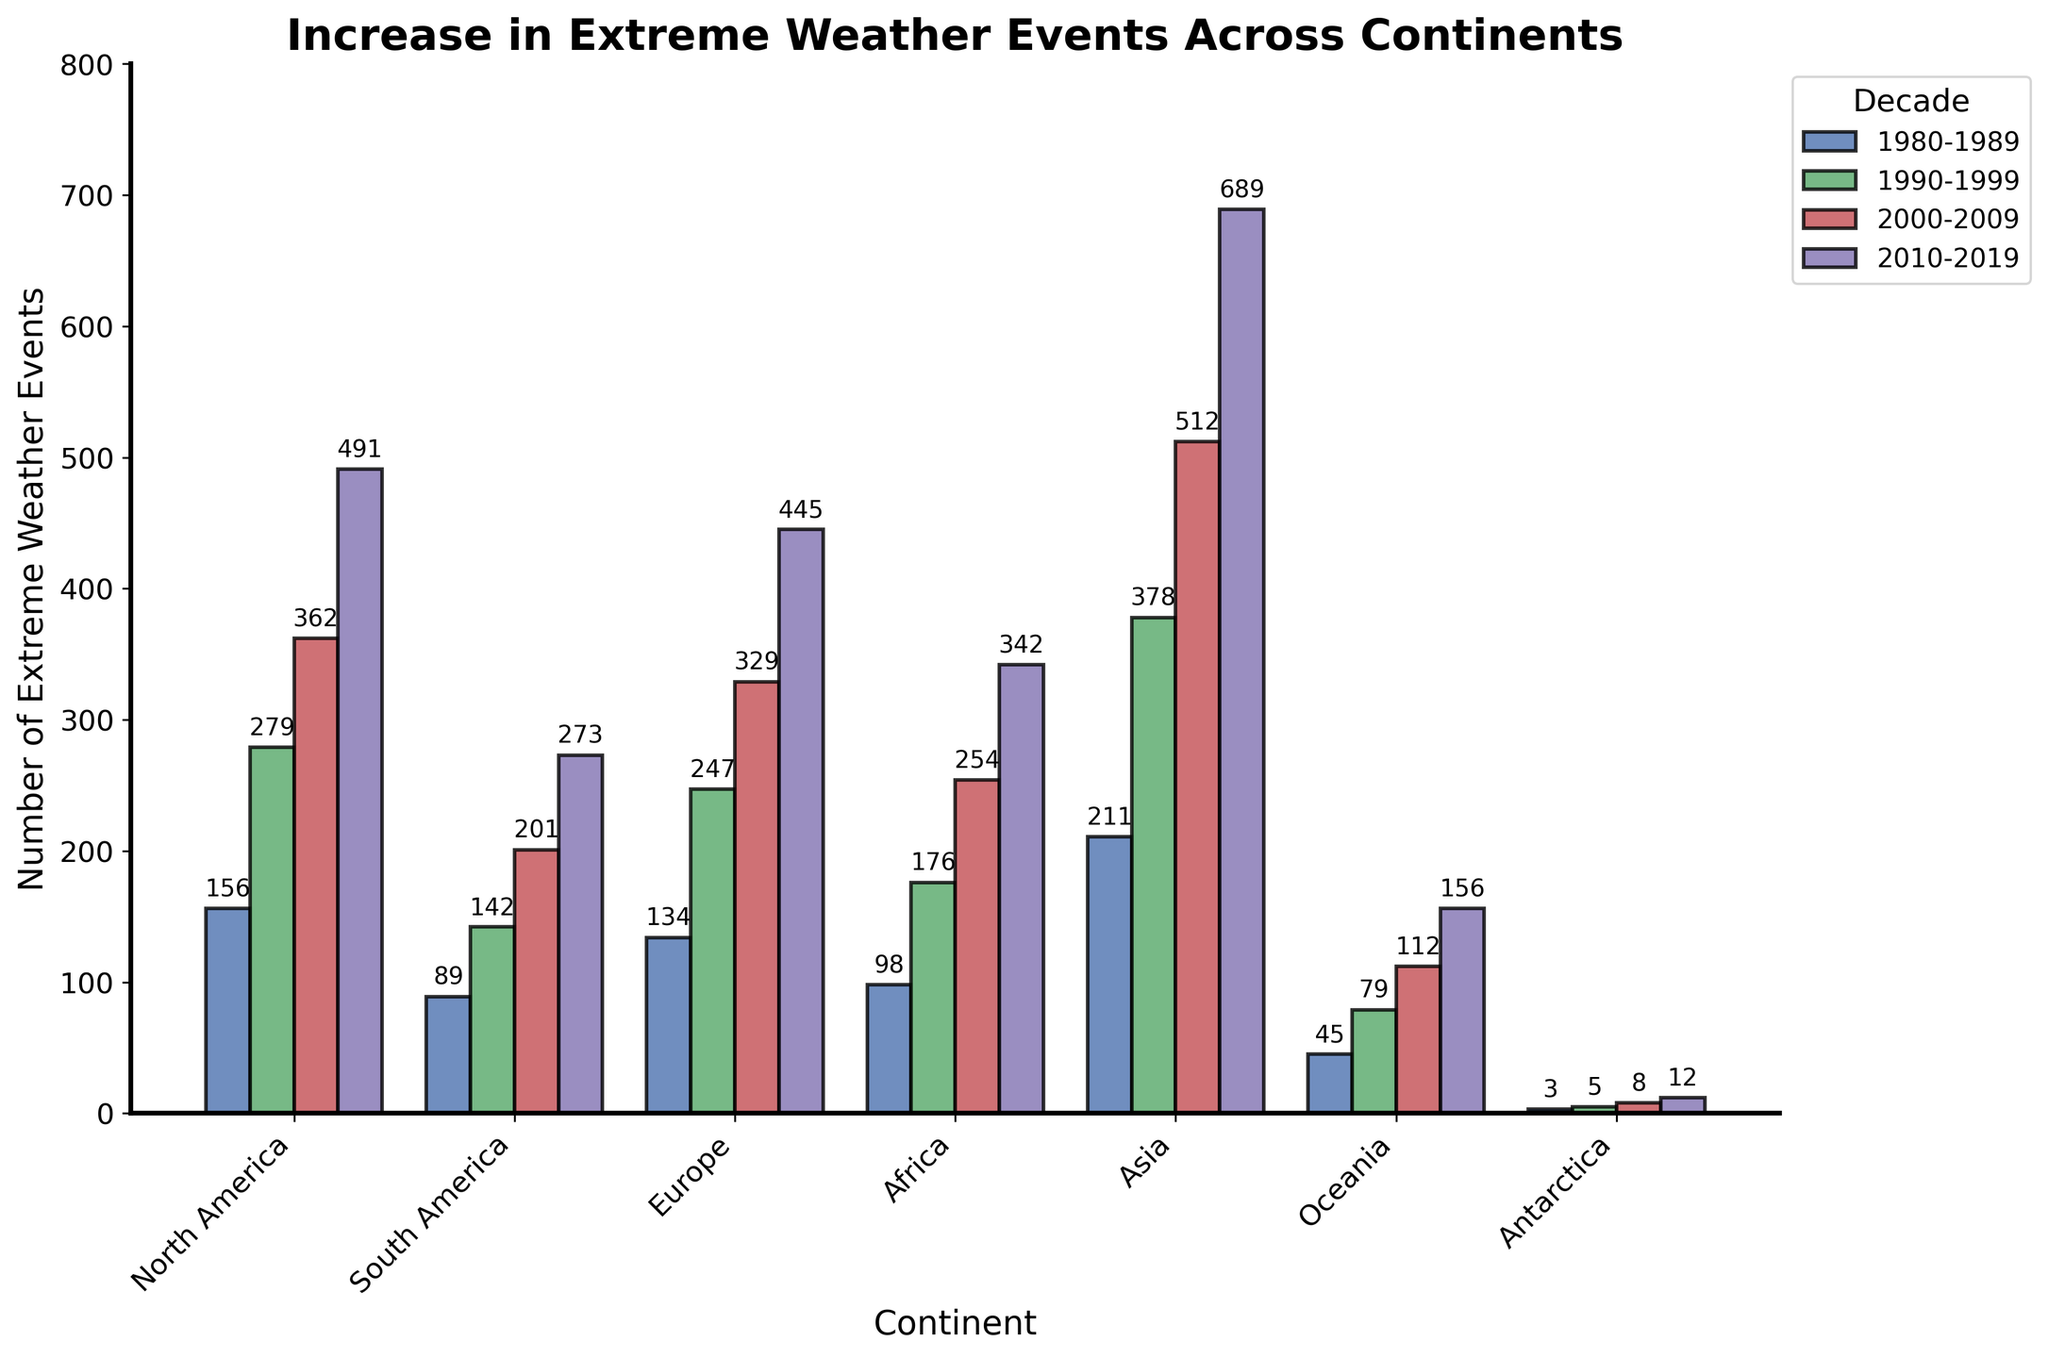How has the number of extreme weather events in North America changed from the 1980s to the 2010s? To understand this, look at the bars representing North America over the decades. Compare the heights of the bars labeled 1980-1989 and 2010-2019. The numbers are 156 in the 1980s and 491 in the 2010s. The extreme weather events in North America increased by (491 - 156) = 335 events.
Answer: Increased by 335 Which continent experienced the largest increase in extreme weather events between 1980-1989 and 2010-2019? Compare the differences in the heights of the bars for each continent from the 1980s to the 2010s. Asia's bars increased from 211 in the 1980s to 689 in the 2010s, which is an increase of 478 – the largest rise among all continents.
Answer: Asia What is the sum of extreme weather events in Europe in the decades shown? Add the values for Europe across the four decades: 134 + 247 + 329 + 445. This results in a total of 1155 events.
Answer: 1155 Which decade saw the highest number of extreme weather events in South America, and how many events were recorded? Look at the bars for South America and identify the highest one, which is in the 2010s with a value of 273.
Answer: 2010-2019, 273 In which decade did Africa see its most significant increase in extreme weather events compared to the previous decade? Compare the bars for Africa by subtracting each decade from the previous one: 1990s (176-98 = 78), 2000s (254-176 = 78), 2010s (342-254 = 88). The largest increase is from the 2000s to the 2010s with an increase of 88 events.
Answer: 2010-2019 How does the number of extreme weather events in Oceania in the 2010s compare to that in Antarctica in the same decade? Compare the height of the bars for Oceania and Antarctica in the 2010s. Oceania has 156 events, whereas Antarctica has 12. Therefore, Oceania has (156 - 12) = 144 more events than Antarctica.
Answer: Oceania has 144 more Determine the average number of extreme weather events in Asia over the decades shown. Add the numbers for Asia over the four decades: 211 + 378 + 512 + 689, which equals 1790. Divide this total by 4 to get the average: 1790 / 4 = 447.5.
Answer: 447.5 Which continent has the fewest total extreme weather events over the four decades, and what is the total number? Sum the events for each continent and compare. Antarctica has (3 + 5 + 8 + 12) = 28 events, which is the fewest.
Answer: Antarctica, 28 What is the difference in the number of extreme weather events between North America and Europe in the decade 2000-2009? Compare the heights of the bars for North America and Europe in the 2000s: North America has 362 and Europe has 329. Thus, the difference is (362 - 329) = 33 events.
Answer: 33 